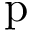Convert formula to latex. <formula><loc_0><loc_0><loc_500><loc_500>p</formula> 